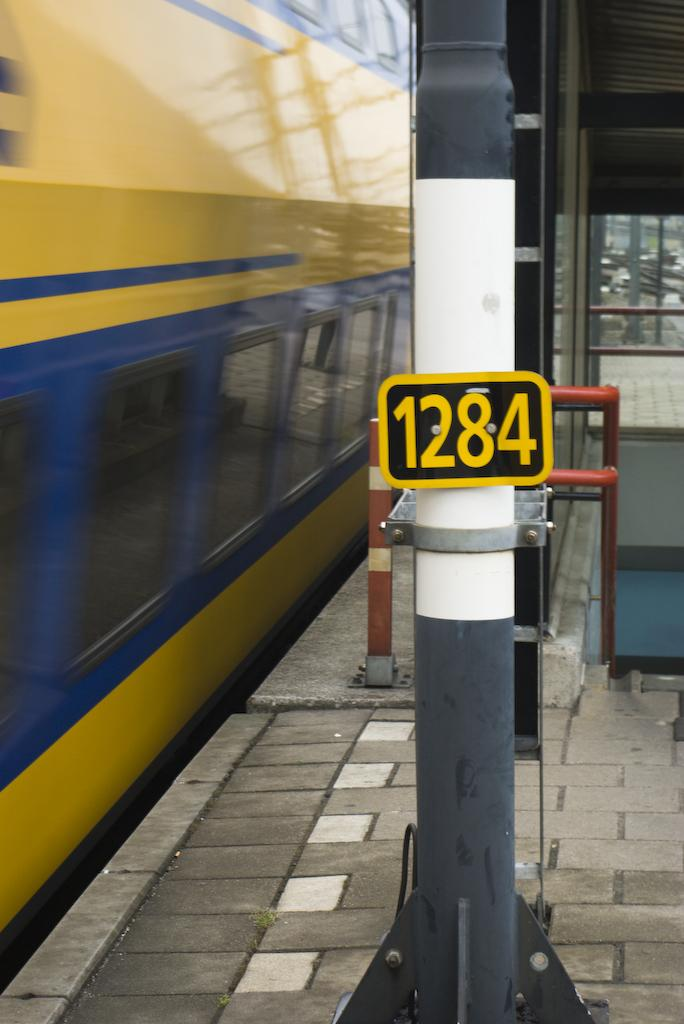<image>
Relay a brief, clear account of the picture shown. The side of a yellow and blue train going by a sign reading 1284. 